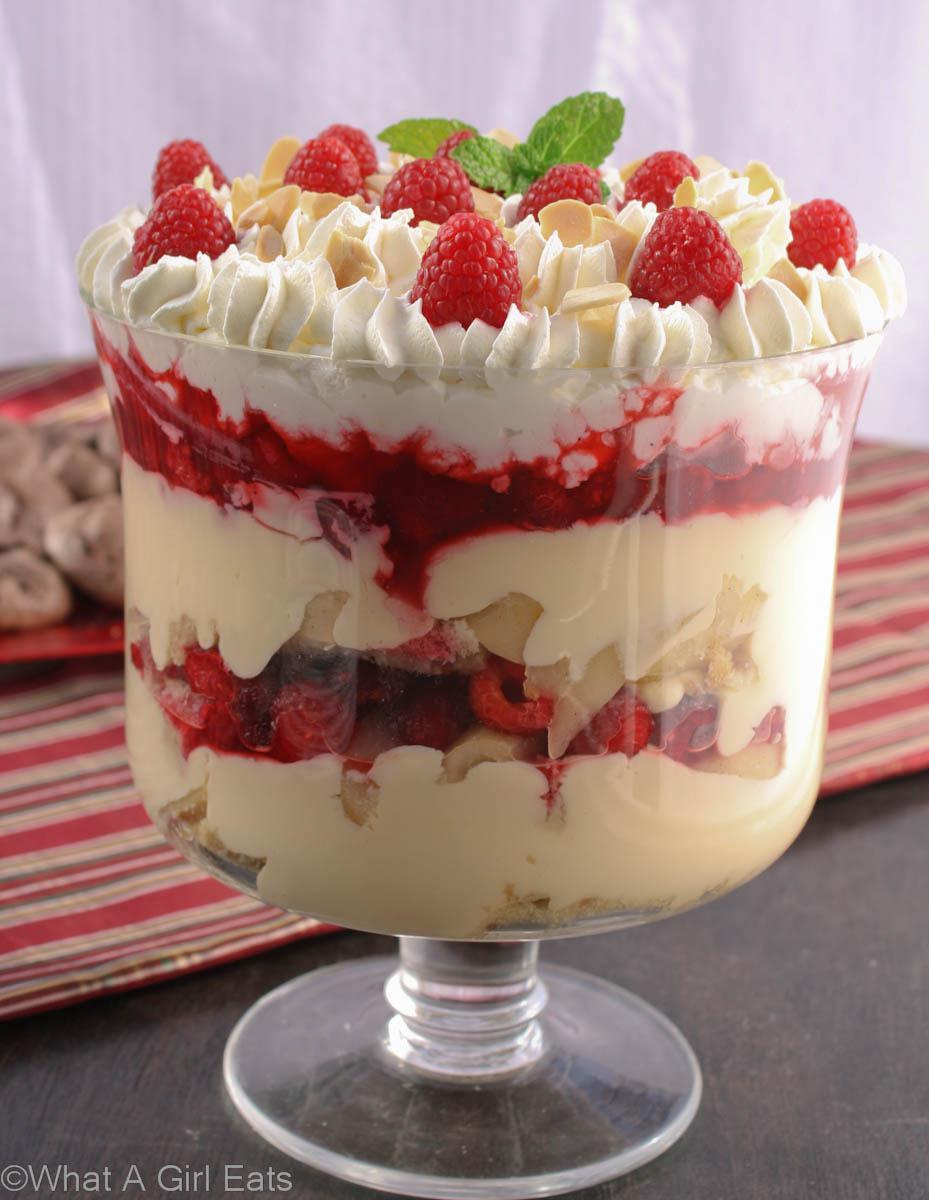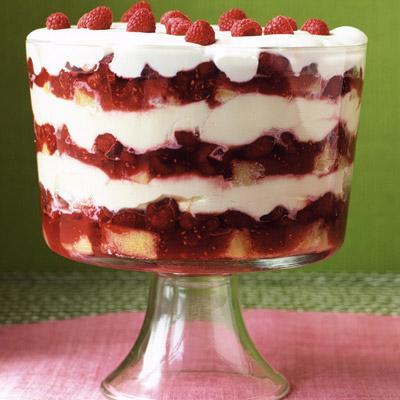The first image is the image on the left, the second image is the image on the right. Evaluate the accuracy of this statement regarding the images: "Two large trifle desserts are made in clear footed bowls with alernating creamy layers and red fruit.". Is it true? Answer yes or no. Yes. The first image is the image on the left, the second image is the image on the right. Considering the images on both sides, is "An image shows a dessert with garnish that includes red berries and a green leaf." valid? Answer yes or no. Yes. 